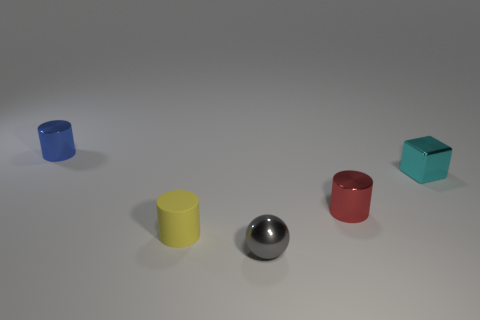Subtract all metallic cylinders. How many cylinders are left? 1 Subtract all red cylinders. How many cylinders are left? 2 Subtract all cylinders. How many objects are left? 2 Subtract 2 cylinders. How many cylinders are left? 1 Subtract all yellow blocks. How many red cylinders are left? 1 Add 5 yellow matte objects. How many yellow matte objects exist? 6 Add 2 big rubber blocks. How many objects exist? 7 Subtract 0 purple cylinders. How many objects are left? 5 Subtract all brown spheres. Subtract all yellow blocks. How many spheres are left? 1 Subtract all large brown metal things. Subtract all gray metallic balls. How many objects are left? 4 